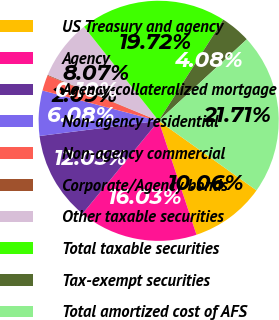Convert chart. <chart><loc_0><loc_0><loc_500><loc_500><pie_chart><fcel>US Treasury and agency<fcel>Agency<fcel>Agency-collateralized mortgage<fcel>Non-agency residential<fcel>Non-agency commercial<fcel>Corporate/Agency bonds<fcel>Other taxable securities<fcel>Total taxable securities<fcel>Tax-exempt securities<fcel>Total amortized cost of AFS<nl><fcel>10.06%<fcel>16.03%<fcel>12.05%<fcel>6.08%<fcel>2.09%<fcel>0.1%<fcel>8.07%<fcel>19.72%<fcel>4.08%<fcel>21.71%<nl></chart> 